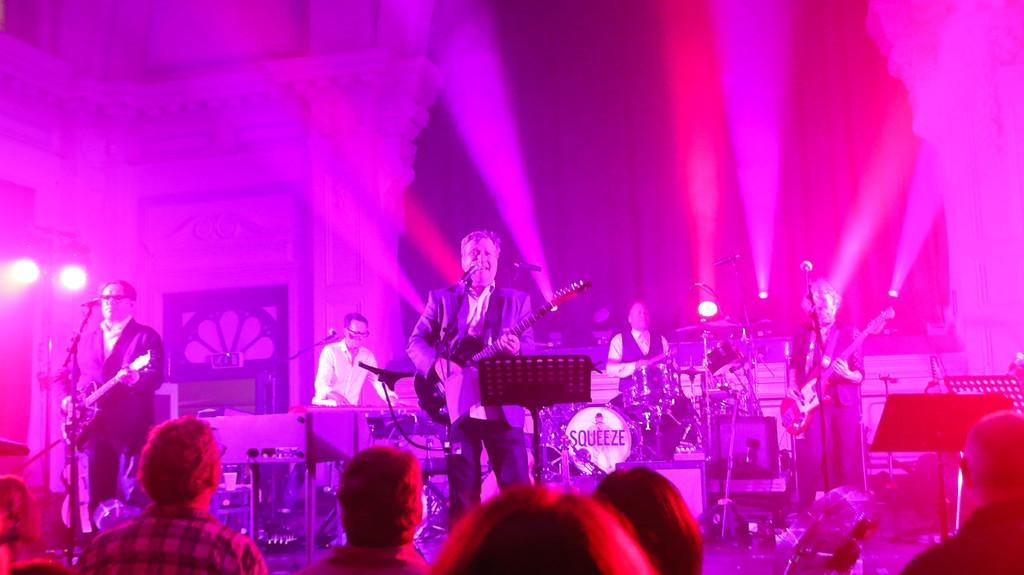How many people are performing in the image? There are 5 people in the image. What are the people doing on stage? The people are singing and playing musical instruments. Can you describe the audience in the image? There are people at the bottom of the image looking at the performers. What type of bear can be seen performing with the group in the image? There is no bear present in the image; the performers are all people. What is the shortest route to the stage in the image? There is no specific route mentioned in the image, as it is a still photograph. 